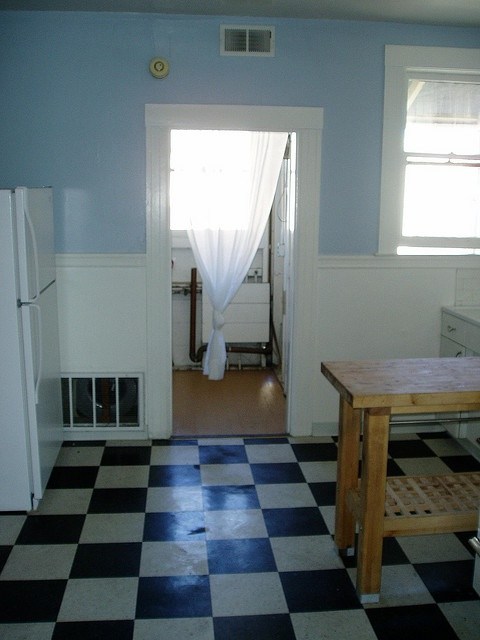Describe the objects in this image and their specific colors. I can see dining table in black, olive, and gray tones and refrigerator in black, gray, and darkgray tones in this image. 